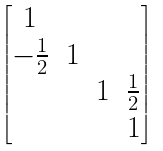<formula> <loc_0><loc_0><loc_500><loc_500>\begin{bmatrix} 1 \\ - \frac { 1 } { 2 } & 1 \\ & & 1 & \frac { 1 } { 2 } \\ & & & 1 \end{bmatrix}</formula> 